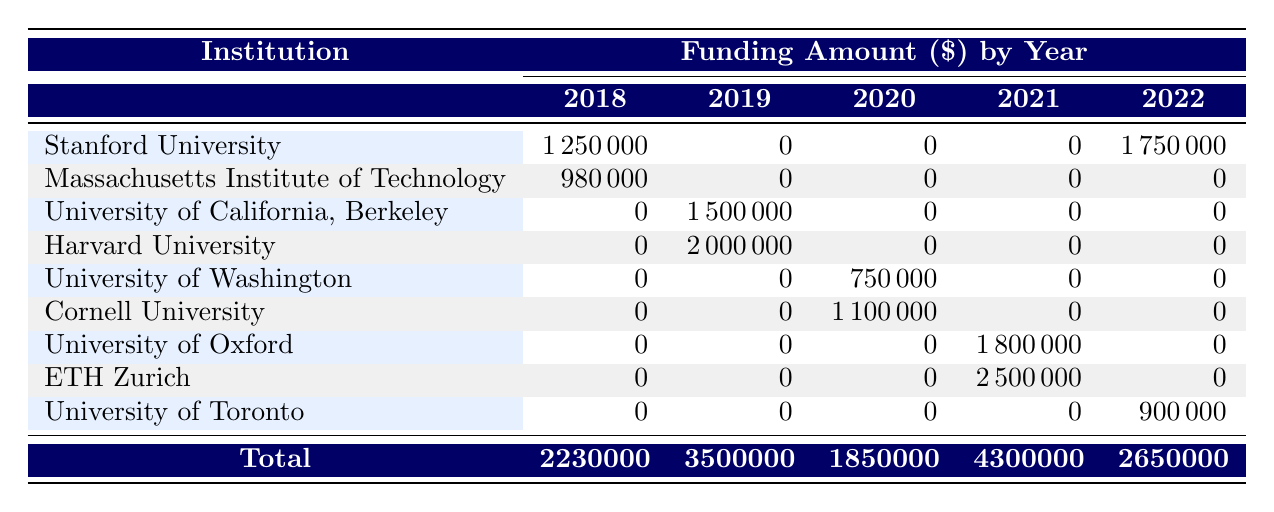What is the total funding amount awarded to Stanford University? The table shows a funding amount of 1,250,000 in 2018 and 1,750,000 in 2022. Adding these amounts gives 1,250,000 + 1,750,000 = 3,000,000.
Answer: 3,000,000 Which institution received the highest funding in 2021? By examining the values in the 2021 column, ETH Zurich received 2,500,000 while the University of Oxford received 1,800,000. Since 2,500,000 is greater than 1,800,000, ETH Zurich received the highest funding in that year.
Answer: ETH Zurich What was the total funding amount for bioinformatics projects in 2019? The amounts for 2019 are 1,500,000 for the University of California, Berkeley and 2,000,000 for Harvard University. Summing these gives 1,500,000 + 2,000,000 = 3,500,000.
Answer: 3,500,000 Did Cornell University receive any funding in 2018? In the table, the funding amount listed for Cornell University in 2018 is 0, indicating that they did not receive any funding that year.
Answer: No What is the difference in funding received between Harvard University and University of Oxford in 2021? Harvard University received no funding in 2021 (0), while the University of Oxford received 1,800,000. The difference can be calculated as 1,800,000 - 0 = 1,800,000.
Answer: 1,800,000 What is the average funding amount received by all institutions in 2020? In 2020, there are two funding amounts: 750,000 for the University of Washington and 1,100,000 for Cornell University. The total funding is 750,000 + 1,100,000 = 1,850,000. There are two institutions, so the average is 1,850,000 / 2 = 925,000.
Answer: 925,000 Which institution received funding from the Bill & Melinda Gates Foundation? According to the table, funding from the Bill & Melinda Gates Foundation was awarded to Harvard University for the project on AI-driven drug discovery for rare diseases.
Answer: Harvard University What was the total funding amount across all institutions in 2022? In 2022, the funding amounts are 1,750,000 for Stanford University and 900,000 for the University of Toronto. Adding these amounts gives 1,750,000 + 900,000 = 2,650,000.
Answer: 2,650,000 Which institution received funding for a project related to quantum computing? The table indicates that ETH Zurich received funding for the project on quantum computing applications in genomics, which is listed under the year 2021.
Answer: ETH Zurich 